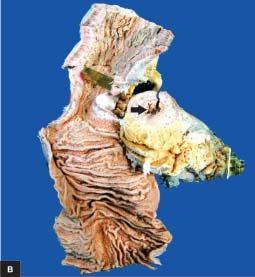does luminal surface of longitudinal cut section show segment of thickened wall with narrow lumen which is better appreciated in cross section while intervening areas of the bowel are uninvolved or skipped?
Answer the question using a single word or phrase. Yes 